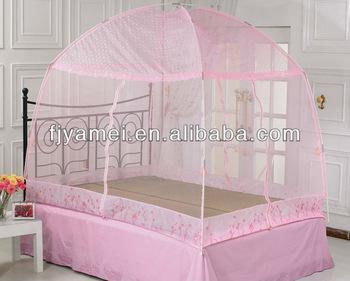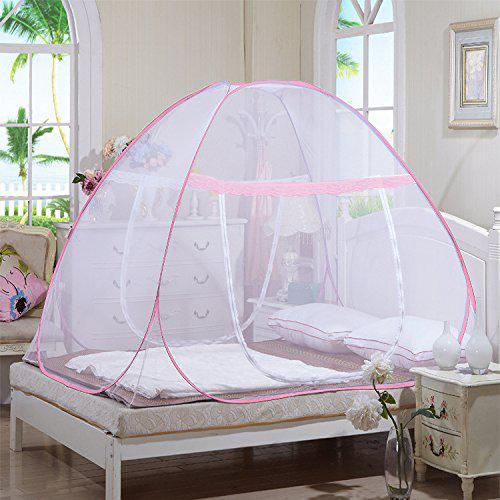The first image is the image on the left, the second image is the image on the right. Evaluate the accuracy of this statement regarding the images: "A bed has a blue-trimmed canopy with a band of patterned fabric around the base.". Is it true? Answer yes or no. No. 